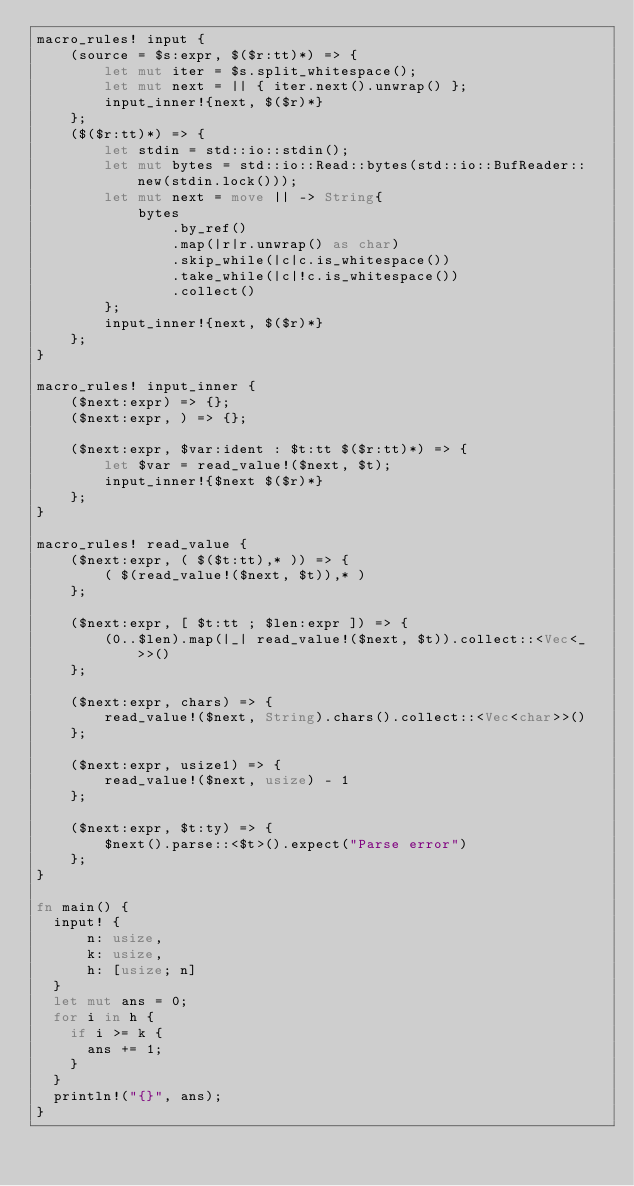Convert code to text. <code><loc_0><loc_0><loc_500><loc_500><_Rust_>macro_rules! input {
    (source = $s:expr, $($r:tt)*) => {
        let mut iter = $s.split_whitespace();
        let mut next = || { iter.next().unwrap() };
        input_inner!{next, $($r)*}
    };
    ($($r:tt)*) => {
        let stdin = std::io::stdin();
        let mut bytes = std::io::Read::bytes(std::io::BufReader::new(stdin.lock()));
        let mut next = move || -> String{
            bytes
                .by_ref()
                .map(|r|r.unwrap() as char)
                .skip_while(|c|c.is_whitespace())
                .take_while(|c|!c.is_whitespace())
                .collect()
        };
        input_inner!{next, $($r)*}
    };
}

macro_rules! input_inner {
    ($next:expr) => {};
    ($next:expr, ) => {};

    ($next:expr, $var:ident : $t:tt $($r:tt)*) => {
        let $var = read_value!($next, $t);
        input_inner!{$next $($r)*}
    };
}

macro_rules! read_value {
    ($next:expr, ( $($t:tt),* )) => {
        ( $(read_value!($next, $t)),* )
    };

    ($next:expr, [ $t:tt ; $len:expr ]) => {
        (0..$len).map(|_| read_value!($next, $t)).collect::<Vec<_>>()
    };

    ($next:expr, chars) => {
        read_value!($next, String).chars().collect::<Vec<char>>()
    };

    ($next:expr, usize1) => {
        read_value!($next, usize) - 1
    };

    ($next:expr, $t:ty) => {
        $next().parse::<$t>().expect("Parse error")
    };
}

fn main() {
  input! {
      n: usize,
      k: usize,
      h: [usize; n]
  }
  let mut ans = 0;
  for i in h {
    if i >= k {
      ans += 1;
    }
  }
  println!("{}", ans);
}
</code> 